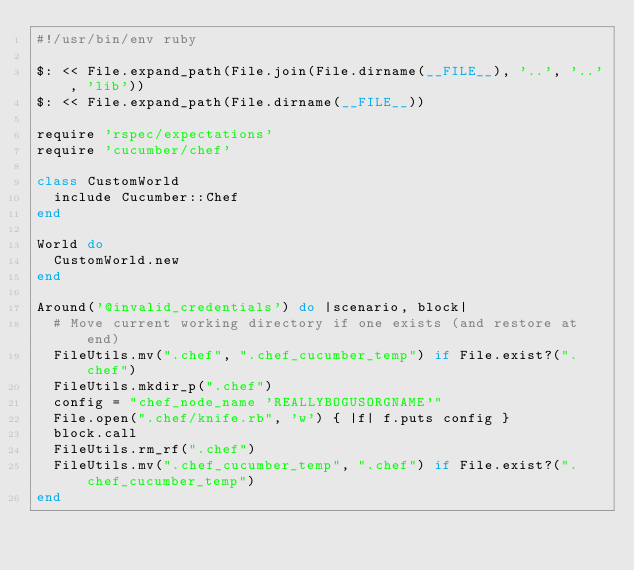Convert code to text. <code><loc_0><loc_0><loc_500><loc_500><_Ruby_>#!/usr/bin/env ruby

$: << File.expand_path(File.join(File.dirname(__FILE__), '..', '..', 'lib'))
$: << File.expand_path(File.dirname(__FILE__))

require 'rspec/expectations'
require 'cucumber/chef'

class CustomWorld
  include Cucumber::Chef
end

World do
  CustomWorld.new
end

Around('@invalid_credentials') do |scenario, block|
  # Move current working directory if one exists (and restore at end)
  FileUtils.mv(".chef", ".chef_cucumber_temp") if File.exist?(".chef")
  FileUtils.mkdir_p(".chef")
  config = "chef_node_name 'REALLYBOGUSORGNAME'"
  File.open(".chef/knife.rb", 'w') { |f| f.puts config }
  block.call
  FileUtils.rm_rf(".chef")
  FileUtils.mv(".chef_cucumber_temp", ".chef") if File.exist?(".chef_cucumber_temp")
end
</code> 